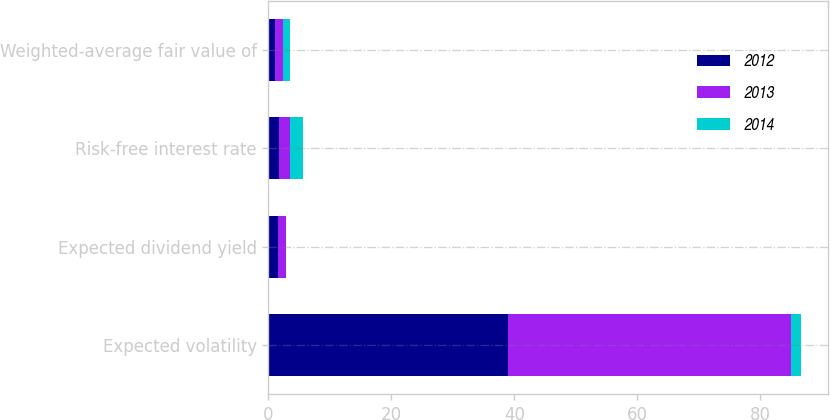Convert chart. <chart><loc_0><loc_0><loc_500><loc_500><stacked_bar_chart><ecel><fcel>Expected volatility<fcel>Expected dividend yield<fcel>Risk-free interest rate<fcel>Weighted-average fair value of<nl><fcel>2012<fcel>39<fcel>1.6<fcel>1.8<fcel>1.06<nl><fcel>2013<fcel>46<fcel>1.2<fcel>1.7<fcel>1.39<nl><fcel>2014<fcel>1.6<fcel>0<fcel>2.1<fcel>1.13<nl></chart> 